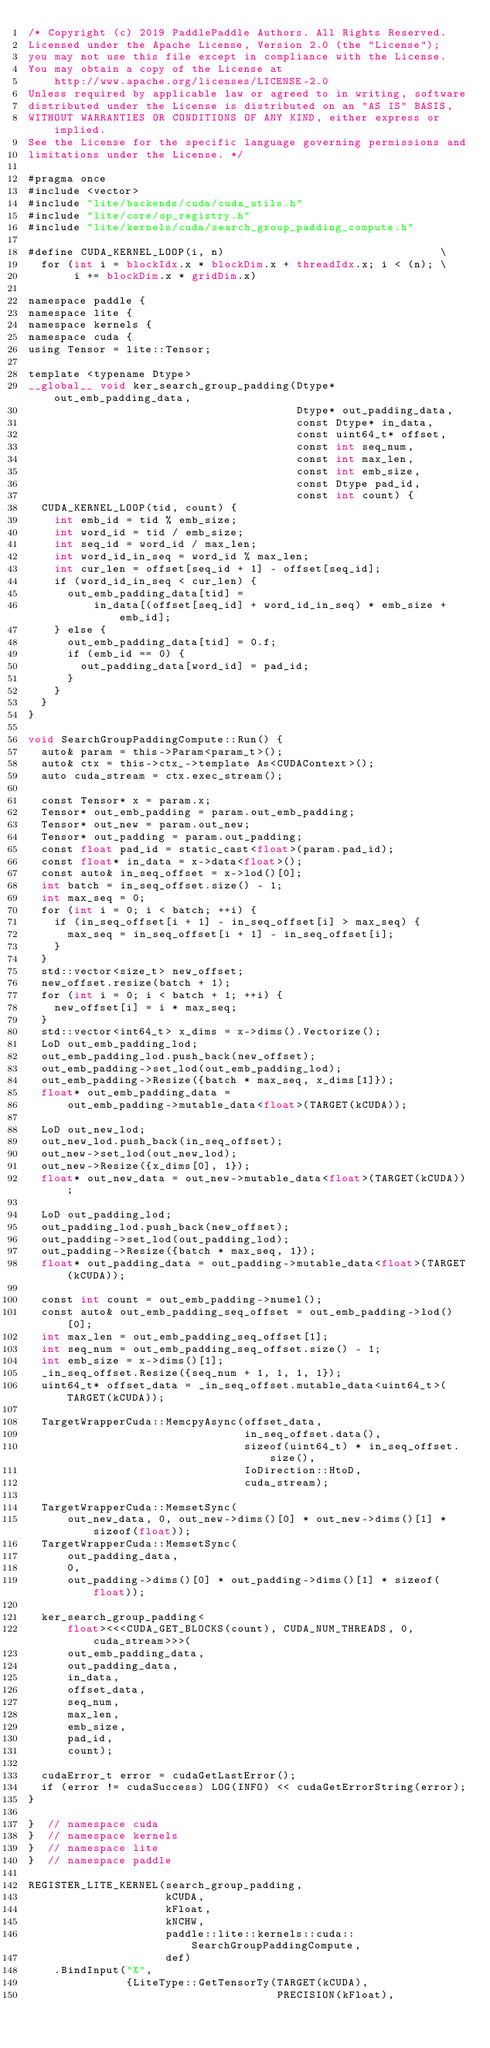<code> <loc_0><loc_0><loc_500><loc_500><_Cuda_>/* Copyright (c) 2019 PaddlePaddle Authors. All Rights Reserved.
Licensed under the Apache License, Version 2.0 (the "License");
you may not use this file except in compliance with the License.
You may obtain a copy of the License at
    http://www.apache.org/licenses/LICENSE-2.0
Unless required by applicable law or agreed to in writing, software
distributed under the License is distributed on an "AS IS" BASIS,
WITHOUT WARRANTIES OR CONDITIONS OF ANY KIND, either express or implied.
See the License for the specific language governing permissions and
limitations under the License. */

#pragma once
#include <vector>
#include "lite/backends/cuda/cuda_utils.h"
#include "lite/core/op_registry.h"
#include "lite/kernels/cuda/search_group_padding_compute.h"

#define CUDA_KERNEL_LOOP(i, n)                                 \
  for (int i = blockIdx.x * blockDim.x + threadIdx.x; i < (n); \
       i += blockDim.x * gridDim.x)

namespace paddle {
namespace lite {
namespace kernels {
namespace cuda {
using Tensor = lite::Tensor;

template <typename Dtype>
__global__ void ker_search_group_padding(Dtype* out_emb_padding_data,
                                         Dtype* out_padding_data,
                                         const Dtype* in_data,
                                         const uint64_t* offset,
                                         const int seq_num,
                                         const int max_len,
                                         const int emb_size,
                                         const Dtype pad_id,
                                         const int count) {
  CUDA_KERNEL_LOOP(tid, count) {
    int emb_id = tid % emb_size;
    int word_id = tid / emb_size;
    int seq_id = word_id / max_len;
    int word_id_in_seq = word_id % max_len;
    int cur_len = offset[seq_id + 1] - offset[seq_id];
    if (word_id_in_seq < cur_len) {
      out_emb_padding_data[tid] =
          in_data[(offset[seq_id] + word_id_in_seq) * emb_size + emb_id];
    } else {
      out_emb_padding_data[tid] = 0.f;
      if (emb_id == 0) {
        out_padding_data[word_id] = pad_id;
      }
    }
  }
}

void SearchGroupPaddingCompute::Run() {
  auto& param = this->Param<param_t>();
  auto& ctx = this->ctx_->template As<CUDAContext>();
  auto cuda_stream = ctx.exec_stream();

  const Tensor* x = param.x;
  Tensor* out_emb_padding = param.out_emb_padding;
  Tensor* out_new = param.out_new;
  Tensor* out_padding = param.out_padding;
  const float pad_id = static_cast<float>(param.pad_id);
  const float* in_data = x->data<float>();
  const auto& in_seq_offset = x->lod()[0];
  int batch = in_seq_offset.size() - 1;
  int max_seq = 0;
  for (int i = 0; i < batch; ++i) {
    if (in_seq_offset[i + 1] - in_seq_offset[i] > max_seq) {
      max_seq = in_seq_offset[i + 1] - in_seq_offset[i];
    }
  }
  std::vector<size_t> new_offset;
  new_offset.resize(batch + 1);
  for (int i = 0; i < batch + 1; ++i) {
    new_offset[i] = i * max_seq;
  }
  std::vector<int64_t> x_dims = x->dims().Vectorize();
  LoD out_emb_padding_lod;
  out_emb_padding_lod.push_back(new_offset);
  out_emb_padding->set_lod(out_emb_padding_lod);
  out_emb_padding->Resize({batch * max_seq, x_dims[1]});
  float* out_emb_padding_data =
      out_emb_padding->mutable_data<float>(TARGET(kCUDA));

  LoD out_new_lod;
  out_new_lod.push_back(in_seq_offset);
  out_new->set_lod(out_new_lod);
  out_new->Resize({x_dims[0], 1});
  float* out_new_data = out_new->mutable_data<float>(TARGET(kCUDA));

  LoD out_padding_lod;
  out_padding_lod.push_back(new_offset);
  out_padding->set_lod(out_padding_lod);
  out_padding->Resize({batch * max_seq, 1});
  float* out_padding_data = out_padding->mutable_data<float>(TARGET(kCUDA));

  const int count = out_emb_padding->numel();
  const auto& out_emb_padding_seq_offset = out_emb_padding->lod()[0];
  int max_len = out_emb_padding_seq_offset[1];
  int seq_num = out_emb_padding_seq_offset.size() - 1;
  int emb_size = x->dims()[1];
  _in_seq_offset.Resize({seq_num + 1, 1, 1, 1});
  uint64_t* offset_data = _in_seq_offset.mutable_data<uint64_t>(TARGET(kCUDA));

  TargetWrapperCuda::MemcpyAsync(offset_data,
                                 in_seq_offset.data(),
                                 sizeof(uint64_t) * in_seq_offset.size(),
                                 IoDirection::HtoD,
                                 cuda_stream);

  TargetWrapperCuda::MemsetSync(
      out_new_data, 0, out_new->dims()[0] * out_new->dims()[1] * sizeof(float));
  TargetWrapperCuda::MemsetSync(
      out_padding_data,
      0,
      out_padding->dims()[0] * out_padding->dims()[1] * sizeof(float));

  ker_search_group_padding<
      float><<<CUDA_GET_BLOCKS(count), CUDA_NUM_THREADS, 0, cuda_stream>>>(
      out_emb_padding_data,
      out_padding_data,
      in_data,
      offset_data,
      seq_num,
      max_len,
      emb_size,
      pad_id,
      count);

  cudaError_t error = cudaGetLastError();
  if (error != cudaSuccess) LOG(INFO) << cudaGetErrorString(error);
}

}  // namespace cuda
}  // namespace kernels
}  // namespace lite
}  // namespace paddle

REGISTER_LITE_KERNEL(search_group_padding,
                     kCUDA,
                     kFloat,
                     kNCHW,
                     paddle::lite::kernels::cuda::SearchGroupPaddingCompute,
                     def)
    .BindInput("X",
               {LiteType::GetTensorTy(TARGET(kCUDA),
                                      PRECISION(kFloat),</code> 